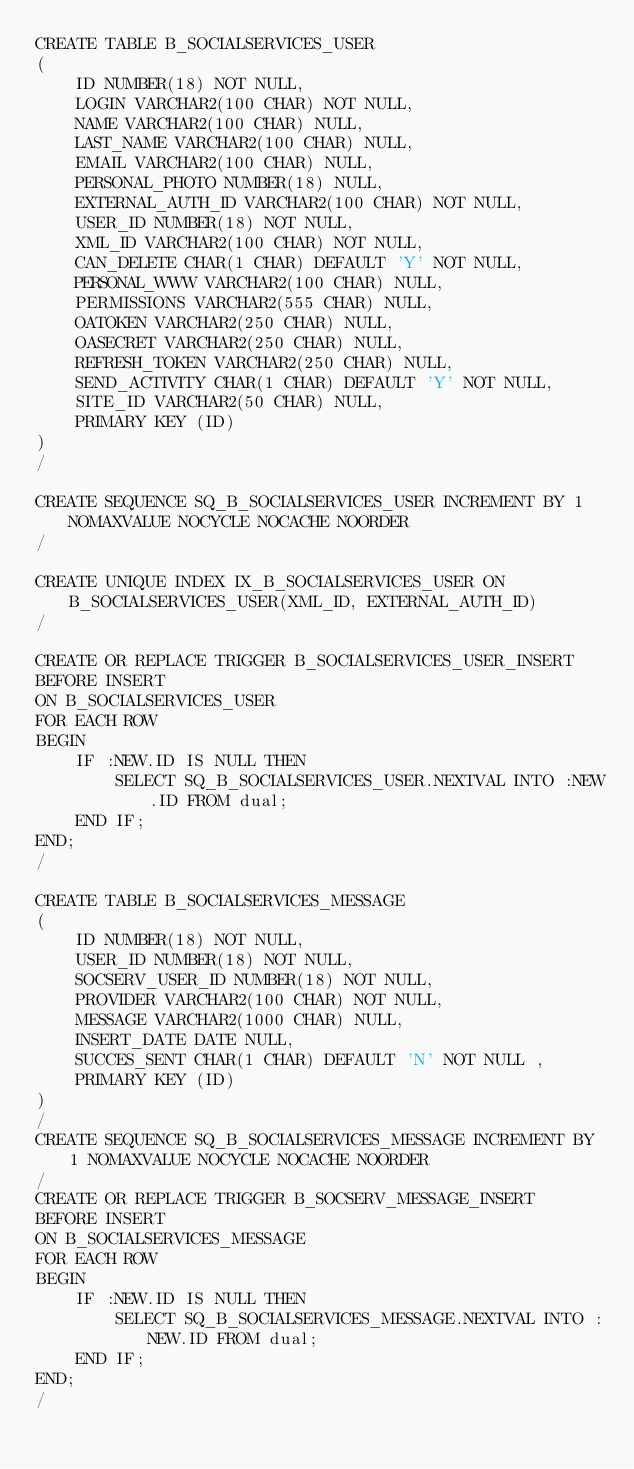Convert code to text. <code><loc_0><loc_0><loc_500><loc_500><_SQL_>CREATE TABLE B_SOCIALSERVICES_USER
(
	ID NUMBER(18) NOT NULL,
	LOGIN VARCHAR2(100 CHAR) NOT NULL,
	NAME VARCHAR2(100 CHAR) NULL,
	LAST_NAME VARCHAR2(100 CHAR) NULL,
	EMAIL VARCHAR2(100 CHAR) NULL,
	PERSONAL_PHOTO NUMBER(18) NULL,
	EXTERNAL_AUTH_ID VARCHAR2(100 CHAR) NOT NULL,
	USER_ID NUMBER(18) NOT NULL,
	XML_ID VARCHAR2(100 CHAR) NOT NULL,
	CAN_DELETE CHAR(1 CHAR) DEFAULT 'Y' NOT NULL,
	PERSONAL_WWW VARCHAR2(100 CHAR) NULL,
	PERMISSIONS VARCHAR2(555 CHAR) NULL,
	OATOKEN VARCHAR2(250 CHAR) NULL,
	OASECRET VARCHAR2(250 CHAR) NULL,
	REFRESH_TOKEN VARCHAR2(250 CHAR) NULL,
	SEND_ACTIVITY CHAR(1 CHAR) DEFAULT 'Y' NOT NULL,
	SITE_ID VARCHAR2(50 CHAR) NULL,
	PRIMARY KEY (ID)
)
/

CREATE SEQUENCE SQ_B_SOCIALSERVICES_USER INCREMENT BY 1 NOMAXVALUE NOCYCLE NOCACHE NOORDER
/

CREATE UNIQUE INDEX IX_B_SOCIALSERVICES_USER ON B_SOCIALSERVICES_USER(XML_ID, EXTERNAL_AUTH_ID)
/

CREATE OR REPLACE TRIGGER B_SOCIALSERVICES_USER_INSERT
BEFORE INSERT
ON B_SOCIALSERVICES_USER
FOR EACH ROW
BEGIN
	IF :NEW.ID IS NULL THEN
 		SELECT SQ_B_SOCIALSERVICES_USER.NEXTVAL INTO :NEW.ID FROM dual;
	END IF;
END;
/

CREATE TABLE B_SOCIALSERVICES_MESSAGE
(
	ID NUMBER(18) NOT NULL,
	USER_ID NUMBER(18) NOT NULL,
	SOCSERV_USER_ID NUMBER(18) NOT NULL,
	PROVIDER VARCHAR2(100 CHAR) NOT NULL,
	MESSAGE VARCHAR2(1000 CHAR) NULL,
	INSERT_DATE DATE NULL,
	SUCCES_SENT CHAR(1 CHAR) DEFAULT 'N' NOT NULL ,
	PRIMARY KEY (ID)
)
/
CREATE SEQUENCE SQ_B_SOCIALSERVICES_MESSAGE INCREMENT BY 1 NOMAXVALUE NOCYCLE NOCACHE NOORDER
/
CREATE OR REPLACE TRIGGER B_SOCSERV_MESSAGE_INSERT
BEFORE INSERT
ON B_SOCIALSERVICES_MESSAGE
FOR EACH ROW
BEGIN
	IF :NEW.ID IS NULL THEN
 		SELECT SQ_B_SOCIALSERVICES_MESSAGE.NEXTVAL INTO :NEW.ID FROM dual;
	END IF;
END;
/</code> 